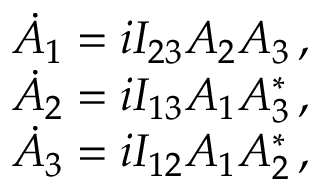<formula> <loc_0><loc_0><loc_500><loc_500>\begin{array} { r } { \dot { A } _ { 1 } = i I _ { 2 3 } A _ { 2 } A _ { 3 } \, , } \\ { \dot { A } _ { 2 } = i I _ { 1 3 } A _ { 1 } A _ { 3 } ^ { * } \, , } \\ { \dot { A } _ { 3 } = i I _ { 1 2 } A _ { 1 } A _ { 2 } ^ { * } \, , } \end{array}</formula> 